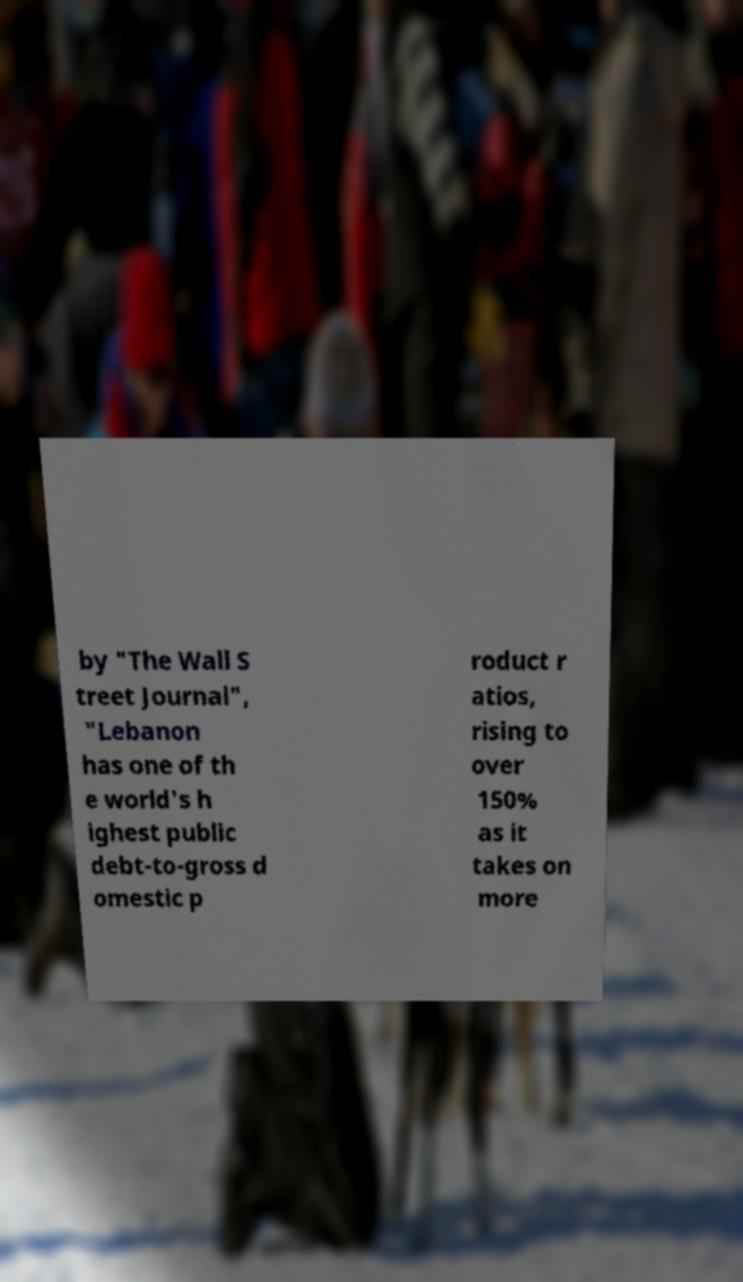Can you read and provide the text displayed in the image?This photo seems to have some interesting text. Can you extract and type it out for me? by "The Wall S treet Journal", "Lebanon has one of th e world's h ighest public debt-to-gross d omestic p roduct r atios, rising to over 150% as it takes on more 